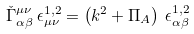Convert formula to latex. <formula><loc_0><loc_0><loc_500><loc_500>\check { \Gamma } _ { \alpha \beta } ^ { \mu \nu } \, \epsilon ^ { 1 , 2 } _ { \mu \nu } = \left ( k ^ { 2 } + \Pi _ { A } \right ) \, \epsilon ^ { 1 , 2 } _ { \alpha \beta }</formula> 